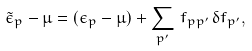Convert formula to latex. <formula><loc_0><loc_0><loc_500><loc_500>\tilde { \epsilon } _ { p } - \mu = ( \epsilon _ { p } - \mu ) + \sum _ { p ^ { \prime } } \, f _ { p p ^ { \prime } } \, \delta f _ { p ^ { \prime } } ,</formula> 